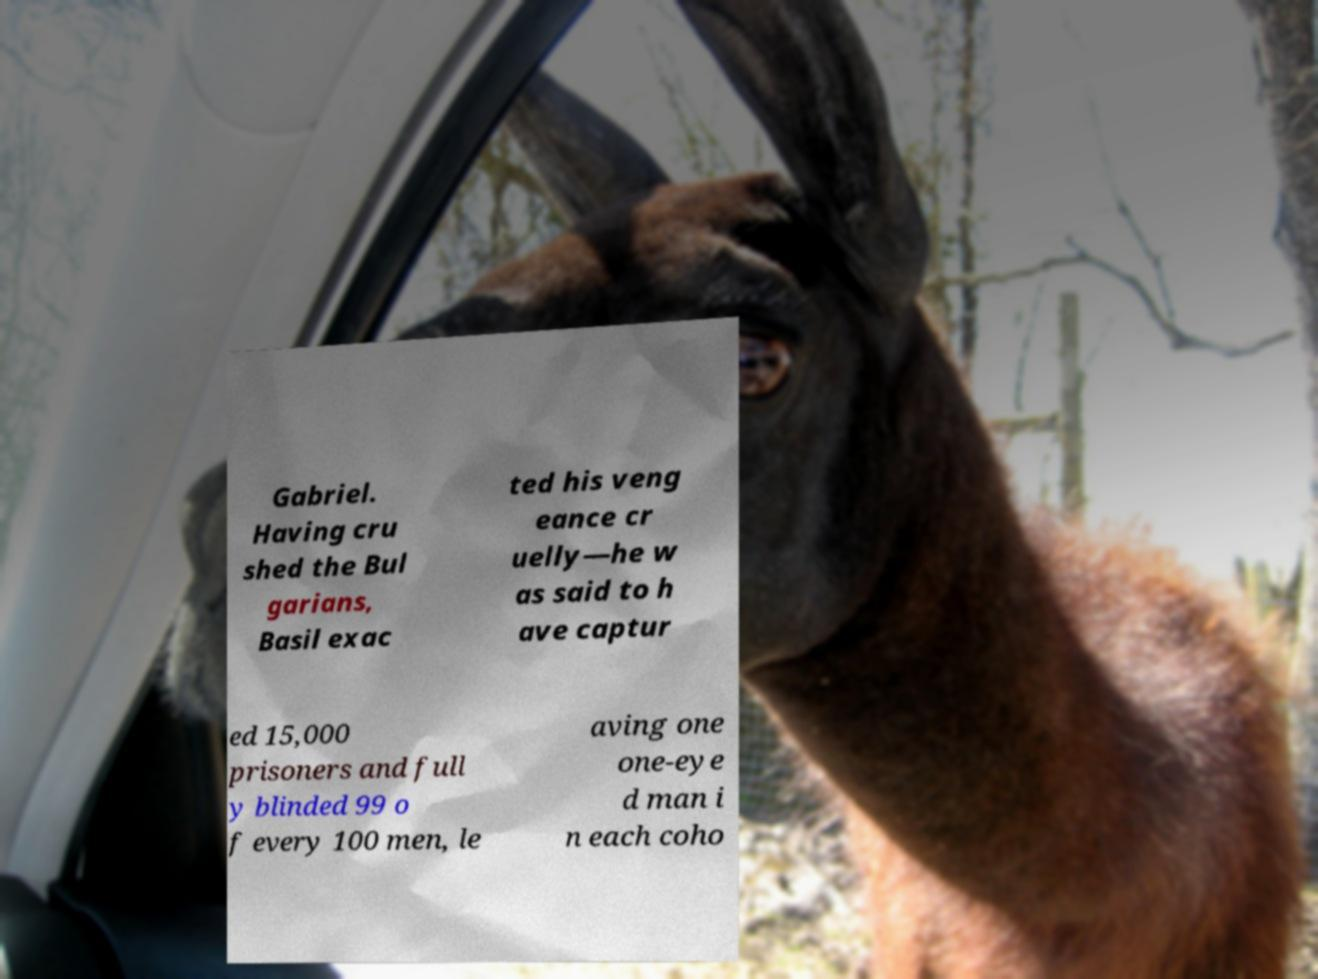Can you read and provide the text displayed in the image?This photo seems to have some interesting text. Can you extract and type it out for me? Gabriel. Having cru shed the Bul garians, Basil exac ted his veng eance cr uelly—he w as said to h ave captur ed 15,000 prisoners and full y blinded 99 o f every 100 men, le aving one one-eye d man i n each coho 